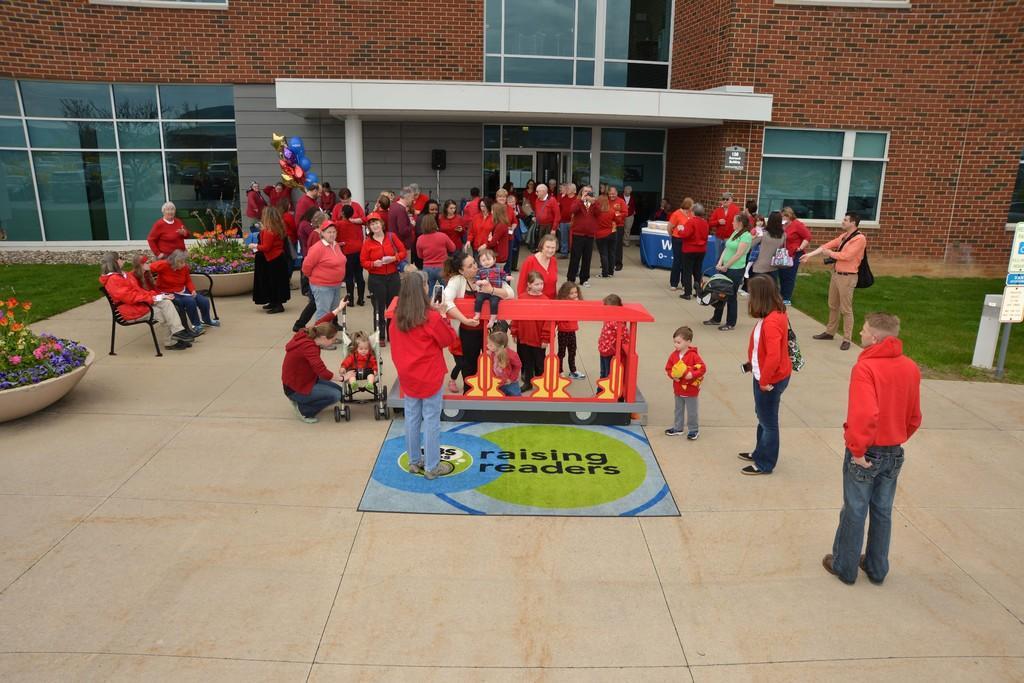How would you summarize this image in a sentence or two? This picture might be taken outside of the building. In this image, in the middle, we can see group of people standing and few people are sitting on the chair. On the right side, we can also see some hoardings. On the left side, we can also see flower pot with some plants and flowers. In the background, we can see a building, glass door, speaker and a brick wall. 